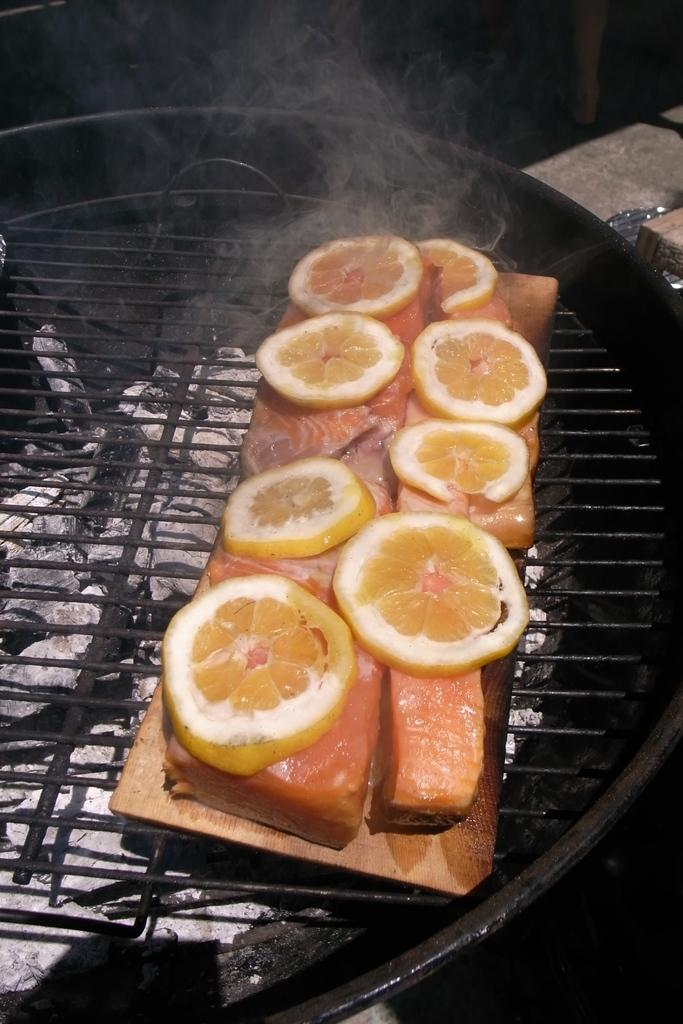What type of food is present in the image? The image contains food, but the specific type cannot be determined from the provided facts. What is the utensil containing liquid used for? The purpose of the utensil containing liquid cannot be determined from the provided facts. What can be observed on the surface of the liquid? There are reflections on the surface of the liquid. What is the presence of smoke suggesting in the image? The presence of smoke suggests that there might be some cooking or heating process taking place in the image. What type of attention is the food receiving in the image? There is no indication in the image that the food is receiving any specific type of attention. What religious symbol can be seen in the image? There is no religious symbol present in the image. 